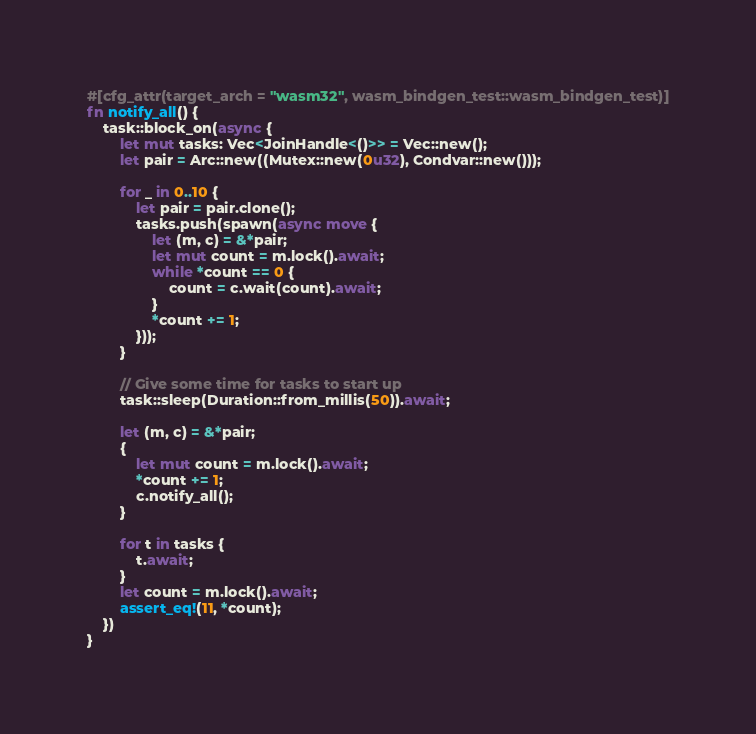Convert code to text. <code><loc_0><loc_0><loc_500><loc_500><_Rust_>#[cfg_attr(target_arch = "wasm32", wasm_bindgen_test::wasm_bindgen_test)]
fn notify_all() {
    task::block_on(async {
        let mut tasks: Vec<JoinHandle<()>> = Vec::new();
        let pair = Arc::new((Mutex::new(0u32), Condvar::new()));

        for _ in 0..10 {
            let pair = pair.clone();
            tasks.push(spawn(async move {
                let (m, c) = &*pair;
                let mut count = m.lock().await;
                while *count == 0 {
                    count = c.wait(count).await;
                }
                *count += 1;
            }));
        }

        // Give some time for tasks to start up
        task::sleep(Duration::from_millis(50)).await;

        let (m, c) = &*pair;
        {
            let mut count = m.lock().await;
            *count += 1;
            c.notify_all();
        }

        for t in tasks {
            t.await;
        }
        let count = m.lock().await;
        assert_eq!(11, *count);
    })
}
</code> 